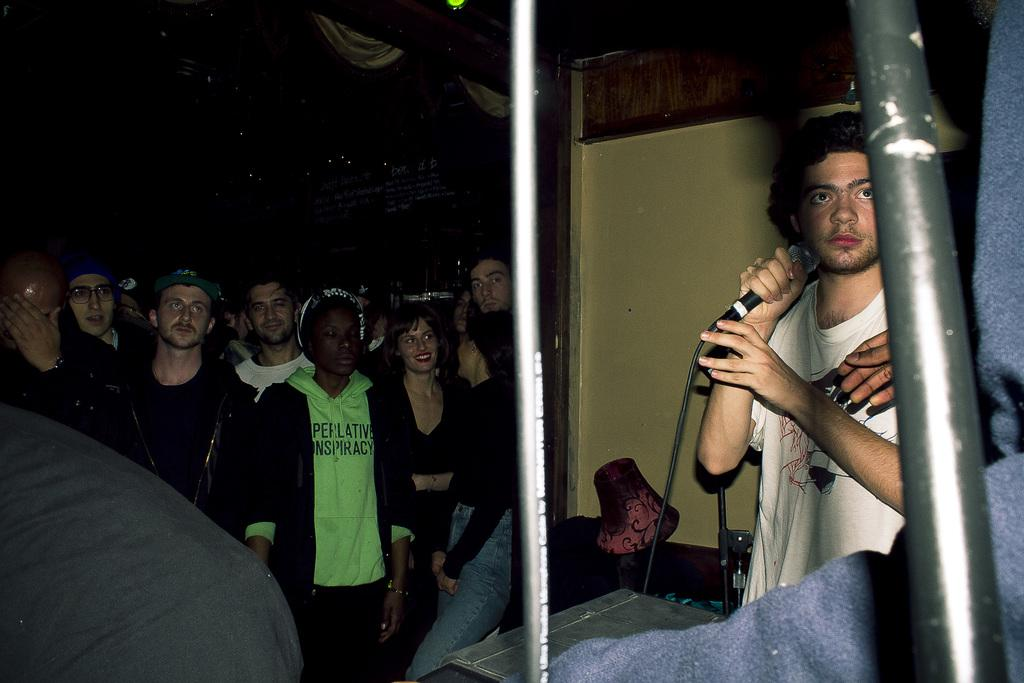How many people are in the image? There are people in the image, but the exact number is not specified. What are some people wearing in the image? Some people are wearing caps in the image. What is one person doing in the image? One person is holding a microphone in the image. What objects can be seen in the image that are used for support? There are rods and stands visible in the image. What is a feature of the background in the image? There is a wall in the image. What type of cover is being offered to the people in the image? There is no mention of a cover being offered to the people in the image. 